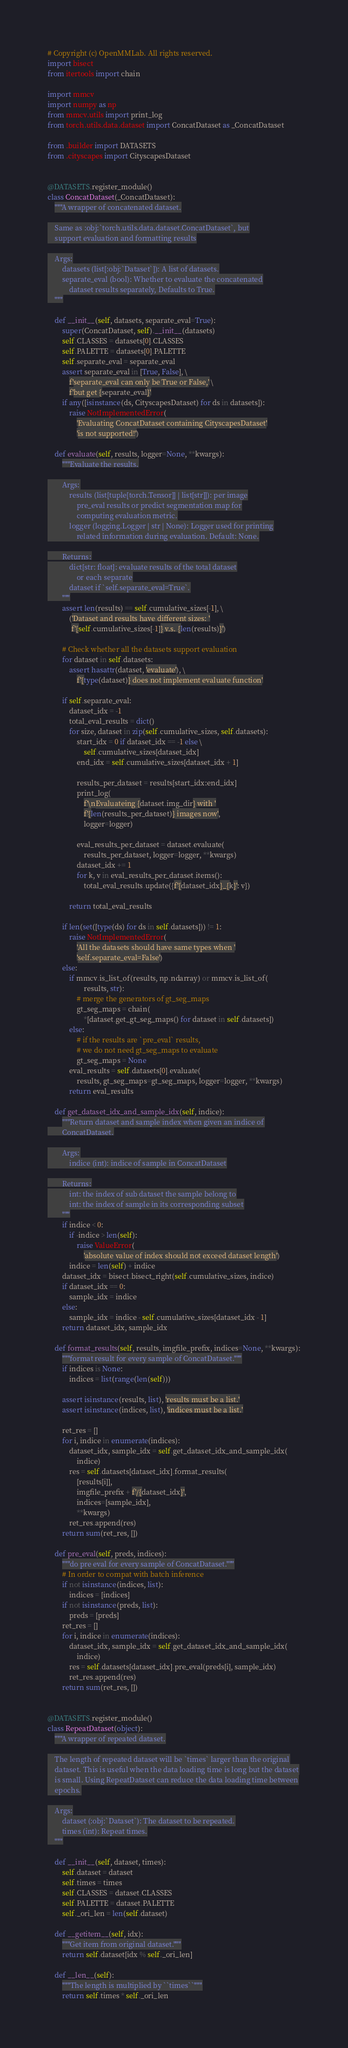<code> <loc_0><loc_0><loc_500><loc_500><_Python_># Copyright (c) OpenMMLab. All rights reserved.
import bisect
from itertools import chain

import mmcv
import numpy as np
from mmcv.utils import print_log
from torch.utils.data.dataset import ConcatDataset as _ConcatDataset

from .builder import DATASETS
from .cityscapes import CityscapesDataset


@DATASETS.register_module()
class ConcatDataset(_ConcatDataset):
    """A wrapper of concatenated dataset.

    Same as :obj:`torch.utils.data.dataset.ConcatDataset`, but
    support evaluation and formatting results

    Args:
        datasets (list[:obj:`Dataset`]): A list of datasets.
        separate_eval (bool): Whether to evaluate the concatenated
            dataset results separately, Defaults to True.
    """

    def __init__(self, datasets, separate_eval=True):
        super(ConcatDataset, self).__init__(datasets)
        self.CLASSES = datasets[0].CLASSES
        self.PALETTE = datasets[0].PALETTE
        self.separate_eval = separate_eval
        assert separate_eval in [True, False], \
            f'separate_eval can only be True or False,' \
            f'but get {separate_eval}'
        if any([isinstance(ds, CityscapesDataset) for ds in datasets]):
            raise NotImplementedError(
                'Evaluating ConcatDataset containing CityscapesDataset'
                'is not supported!')

    def evaluate(self, results, logger=None, **kwargs):
        """Evaluate the results.

        Args:
            results (list[tuple[torch.Tensor]] | list[str]]): per image
                pre_eval results or predict segmentation map for
                computing evaluation metric.
            logger (logging.Logger | str | None): Logger used for printing
                related information during evaluation. Default: None.

        Returns:
            dict[str: float]: evaluate results of the total dataset
                or each separate
            dataset if `self.separate_eval=True`.
        """
        assert len(results) == self.cumulative_sizes[-1], \
            ('Dataset and results have different sizes: '
             f'{self.cumulative_sizes[-1]} v.s. {len(results)}')

        # Check whether all the datasets support evaluation
        for dataset in self.datasets:
            assert hasattr(dataset, 'evaluate'), \
                f'{type(dataset)} does not implement evaluate function'

        if self.separate_eval:
            dataset_idx = -1
            total_eval_results = dict()
            for size, dataset in zip(self.cumulative_sizes, self.datasets):
                start_idx = 0 if dataset_idx == -1 else \
                    self.cumulative_sizes[dataset_idx]
                end_idx = self.cumulative_sizes[dataset_idx + 1]

                results_per_dataset = results[start_idx:end_idx]
                print_log(
                    f'\nEvaluateing {dataset.img_dir} with '
                    f'{len(results_per_dataset)} images now',
                    logger=logger)

                eval_results_per_dataset = dataset.evaluate(
                    results_per_dataset, logger=logger, **kwargs)
                dataset_idx += 1
                for k, v in eval_results_per_dataset.items():
                    total_eval_results.update({f'{dataset_idx}_{k}': v})

            return total_eval_results

        if len(set([type(ds) for ds in self.datasets])) != 1:
            raise NotImplementedError(
                'All the datasets should have same types when '
                'self.separate_eval=False')
        else:
            if mmcv.is_list_of(results, np.ndarray) or mmcv.is_list_of(
                    results, str):
                # merge the generators of gt_seg_maps
                gt_seg_maps = chain(
                    *[dataset.get_gt_seg_maps() for dataset in self.datasets])
            else:
                # if the results are `pre_eval` results,
                # we do not need gt_seg_maps to evaluate
                gt_seg_maps = None
            eval_results = self.datasets[0].evaluate(
                results, gt_seg_maps=gt_seg_maps, logger=logger, **kwargs)
            return eval_results

    def get_dataset_idx_and_sample_idx(self, indice):
        """Return dataset and sample index when given an indice of
        ConcatDataset.

        Args:
            indice (int): indice of sample in ConcatDataset

        Returns:
            int: the index of sub dataset the sample belong to
            int: the index of sample in its corresponding subset
        """
        if indice < 0:
            if -indice > len(self):
                raise ValueError(
                    'absolute value of index should not exceed dataset length')
            indice = len(self) + indice
        dataset_idx = bisect.bisect_right(self.cumulative_sizes, indice)
        if dataset_idx == 0:
            sample_idx = indice
        else:
            sample_idx = indice - self.cumulative_sizes[dataset_idx - 1]
        return dataset_idx, sample_idx

    def format_results(self, results, imgfile_prefix, indices=None, **kwargs):
        """format result for every sample of ConcatDataset."""
        if indices is None:
            indices = list(range(len(self)))

        assert isinstance(results, list), 'results must be a list.'
        assert isinstance(indices, list), 'indices must be a list.'

        ret_res = []
        for i, indice in enumerate(indices):
            dataset_idx, sample_idx = self.get_dataset_idx_and_sample_idx(
                indice)
            res = self.datasets[dataset_idx].format_results(
                [results[i]],
                imgfile_prefix + f'/{dataset_idx}',
                indices=[sample_idx],
                **kwargs)
            ret_res.append(res)
        return sum(ret_res, [])

    def pre_eval(self, preds, indices):
        """do pre eval for every sample of ConcatDataset."""
        # In order to compat with batch inference
        if not isinstance(indices, list):
            indices = [indices]
        if not isinstance(preds, list):
            preds = [preds]
        ret_res = []
        for i, indice in enumerate(indices):
            dataset_idx, sample_idx = self.get_dataset_idx_and_sample_idx(
                indice)
            res = self.datasets[dataset_idx].pre_eval(preds[i], sample_idx)
            ret_res.append(res)
        return sum(ret_res, [])


@DATASETS.register_module()
class RepeatDataset(object):
    """A wrapper of repeated dataset.

    The length of repeated dataset will be `times` larger than the original
    dataset. This is useful when the data loading time is long but the dataset
    is small. Using RepeatDataset can reduce the data loading time between
    epochs.

    Args:
        dataset (:obj:`Dataset`): The dataset to be repeated.
        times (int): Repeat times.
    """

    def __init__(self, dataset, times):
        self.dataset = dataset
        self.times = times
        self.CLASSES = dataset.CLASSES
        self.PALETTE = dataset.PALETTE
        self._ori_len = len(self.dataset)

    def __getitem__(self, idx):
        """Get item from original dataset."""
        return self.dataset[idx % self._ori_len]

    def __len__(self):
        """The length is multiplied by ``times``"""
        return self.times * self._ori_len
</code> 